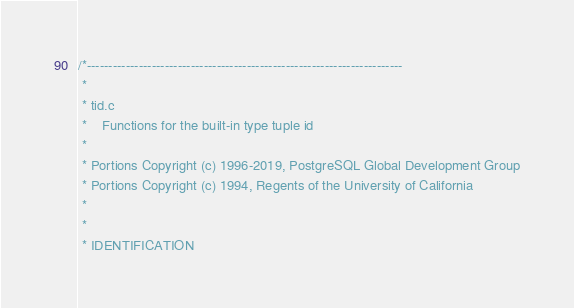Convert code to text. <code><loc_0><loc_0><loc_500><loc_500><_C_>/*-------------------------------------------------------------------------
 *
 * tid.c
 *	  Functions for the built-in type tuple id
 *
 * Portions Copyright (c) 1996-2019, PostgreSQL Global Development Group
 * Portions Copyright (c) 1994, Regents of the University of California
 *
 *
 * IDENTIFICATION</code> 